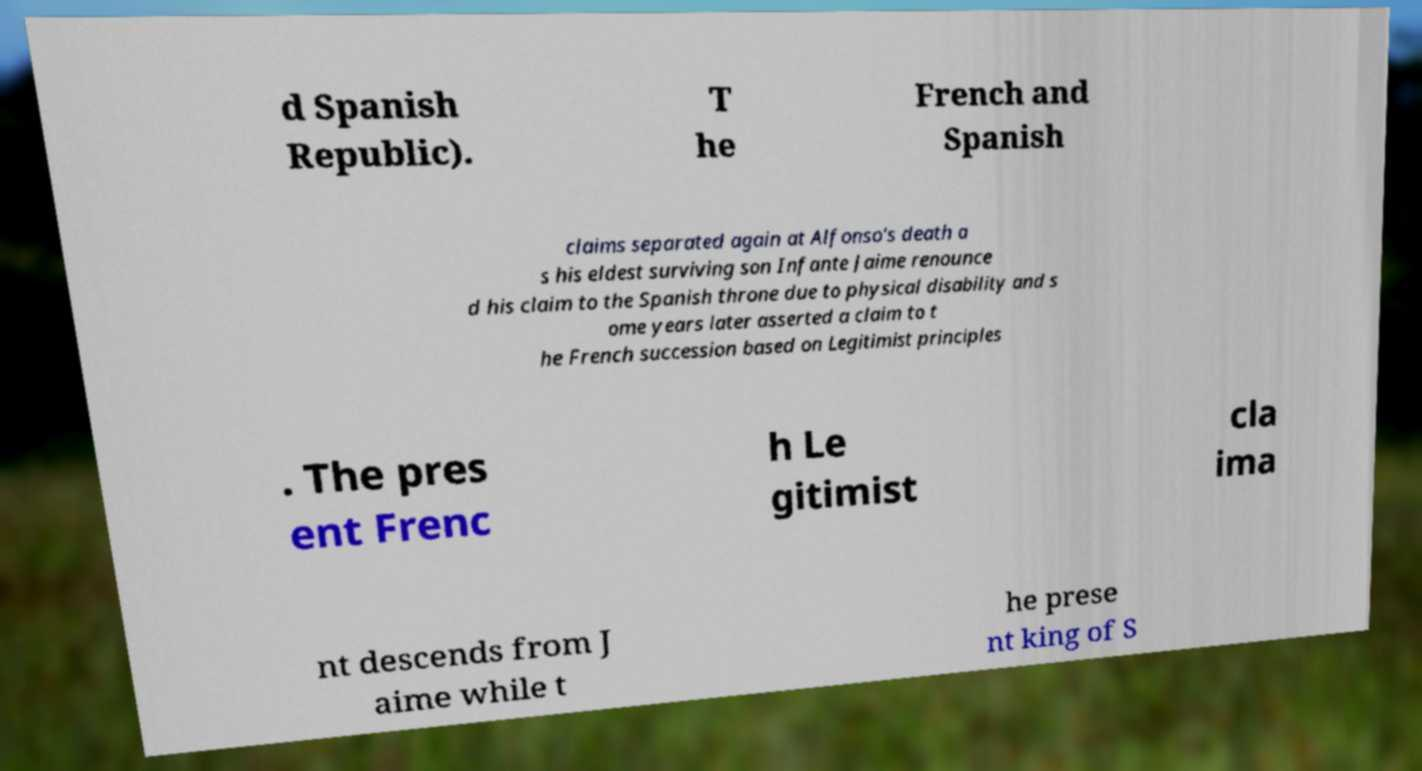Please read and relay the text visible in this image. What does it say? d Spanish Republic). T he French and Spanish claims separated again at Alfonso's death a s his eldest surviving son Infante Jaime renounce d his claim to the Spanish throne due to physical disability and s ome years later asserted a claim to t he French succession based on Legitimist principles . The pres ent Frenc h Le gitimist cla ima nt descends from J aime while t he prese nt king of S 